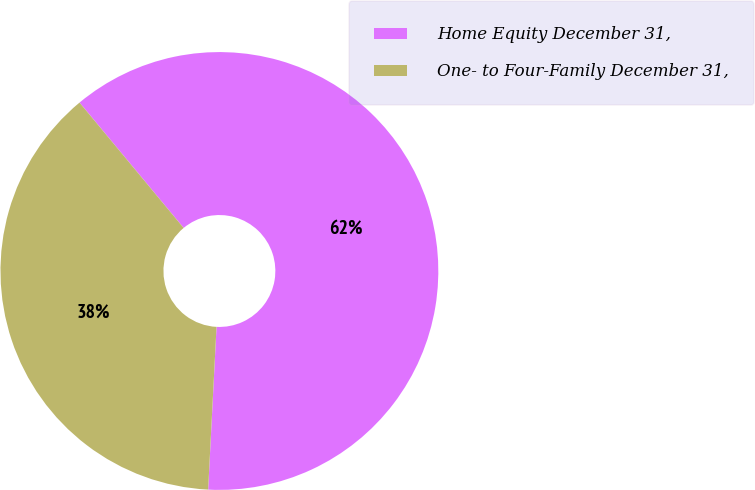Convert chart to OTSL. <chart><loc_0><loc_0><loc_500><loc_500><pie_chart><fcel>Home Equity December 31,<fcel>One- to Four-Family December 31,<nl><fcel>61.85%<fcel>38.15%<nl></chart> 